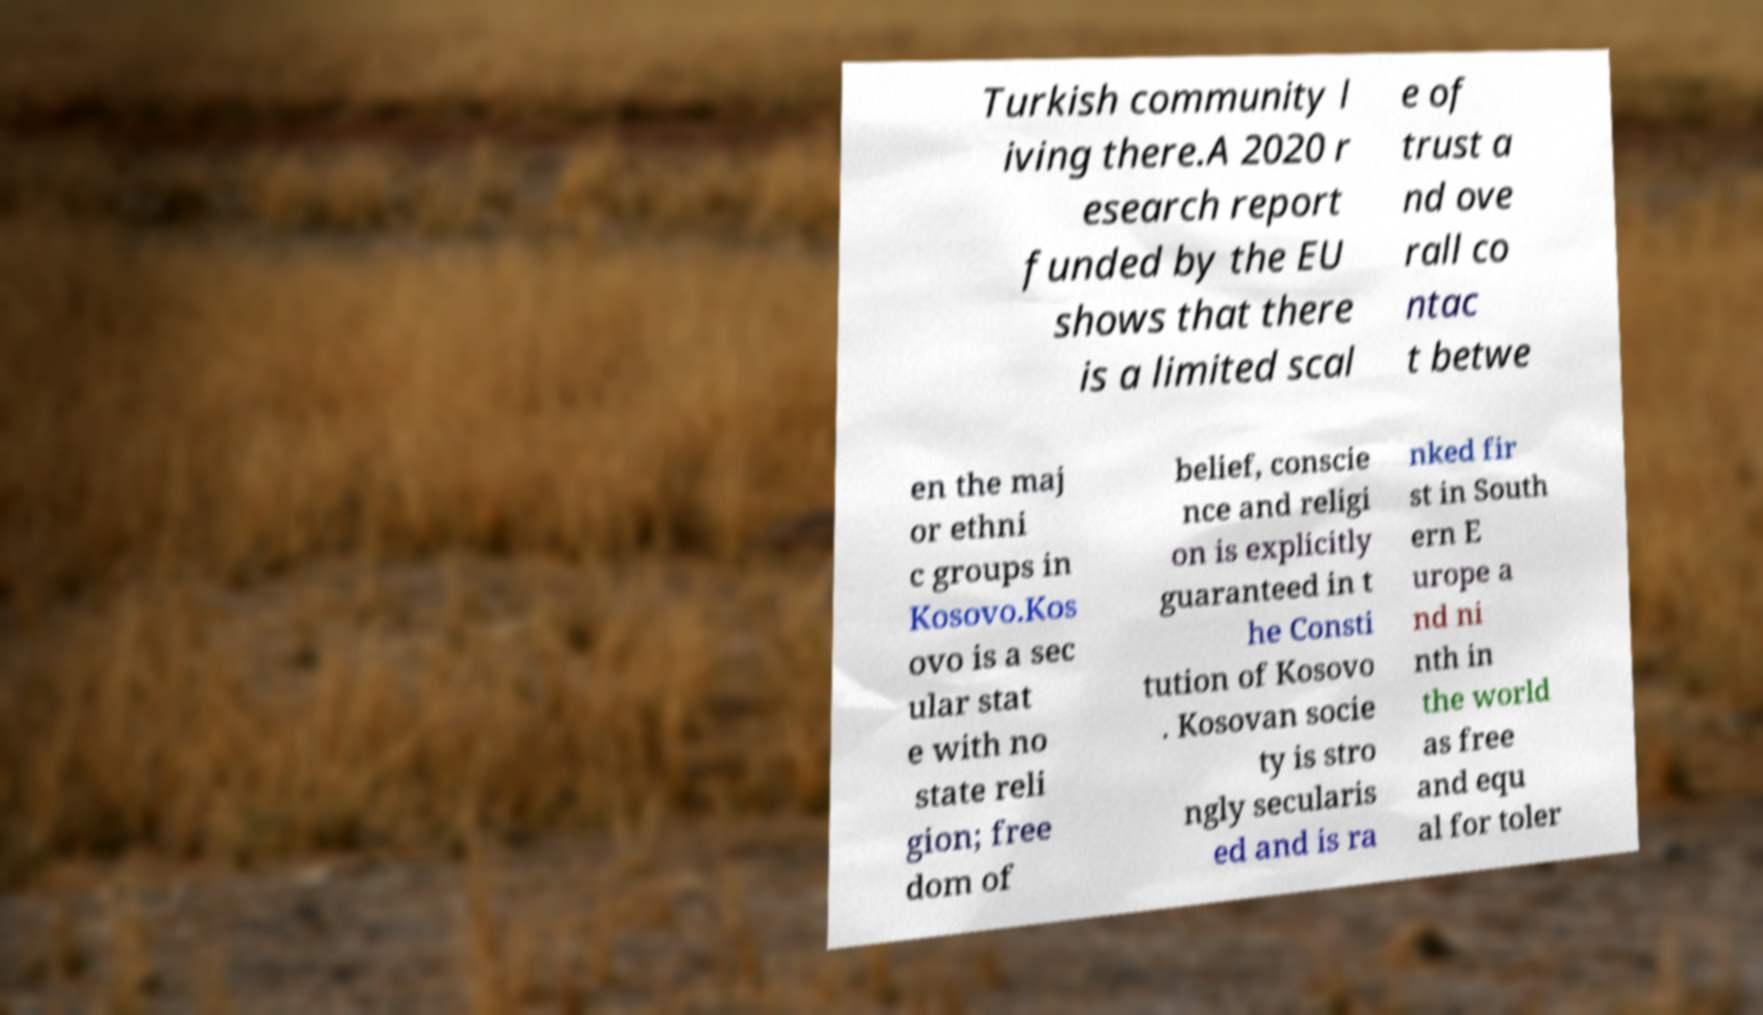For documentation purposes, I need the text within this image transcribed. Could you provide that? Turkish community l iving there.A 2020 r esearch report funded by the EU shows that there is a limited scal e of trust a nd ove rall co ntac t betwe en the maj or ethni c groups in Kosovo.Kos ovo is a sec ular stat e with no state reli gion; free dom of belief, conscie nce and religi on is explicitly guaranteed in t he Consti tution of Kosovo . Kosovan socie ty is stro ngly secularis ed and is ra nked fir st in South ern E urope a nd ni nth in the world as free and equ al for toler 